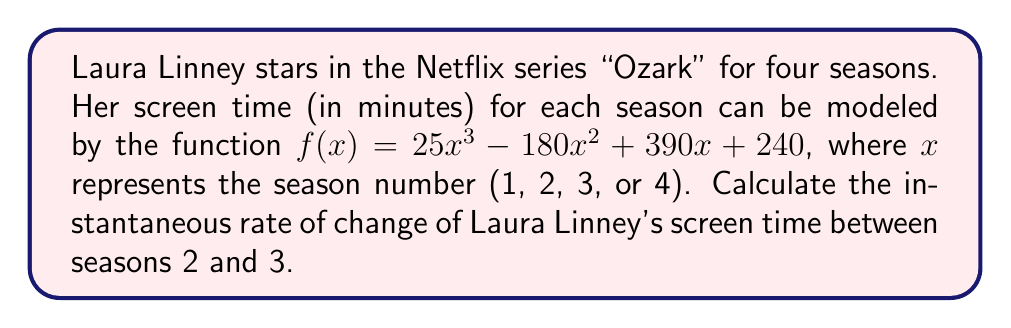Could you help me with this problem? To solve this problem, we need to find the derivative of the given function and evaluate it at the midpoint between seasons 2 and 3. Here's the step-by-step process:

1) First, let's find the derivative of $f(x)$:
   $$f'(x) = 75x^2 - 360x + 390$$

2) The midpoint between seasons 2 and 3 is 2.5. We'll evaluate $f'(x)$ at $x = 2.5$:
   $$f'(2.5) = 75(2.5)^2 - 360(2.5) + 390$$

3) Let's calculate each term:
   $$75(2.5)^2 = 75(6.25) = 468.75$$
   $$-360(2.5) = -900$$
   $$390$$

4) Now, we can add these terms:
   $$f'(2.5) = 468.75 - 900 + 390 = -41.25$$

The negative value indicates that Laura Linney's screen time is decreasing at this point between seasons 2 and 3.
Answer: The instantaneous rate of change of Laura Linney's screen time between seasons 2 and 3 is $-41.25$ minutes per season. 